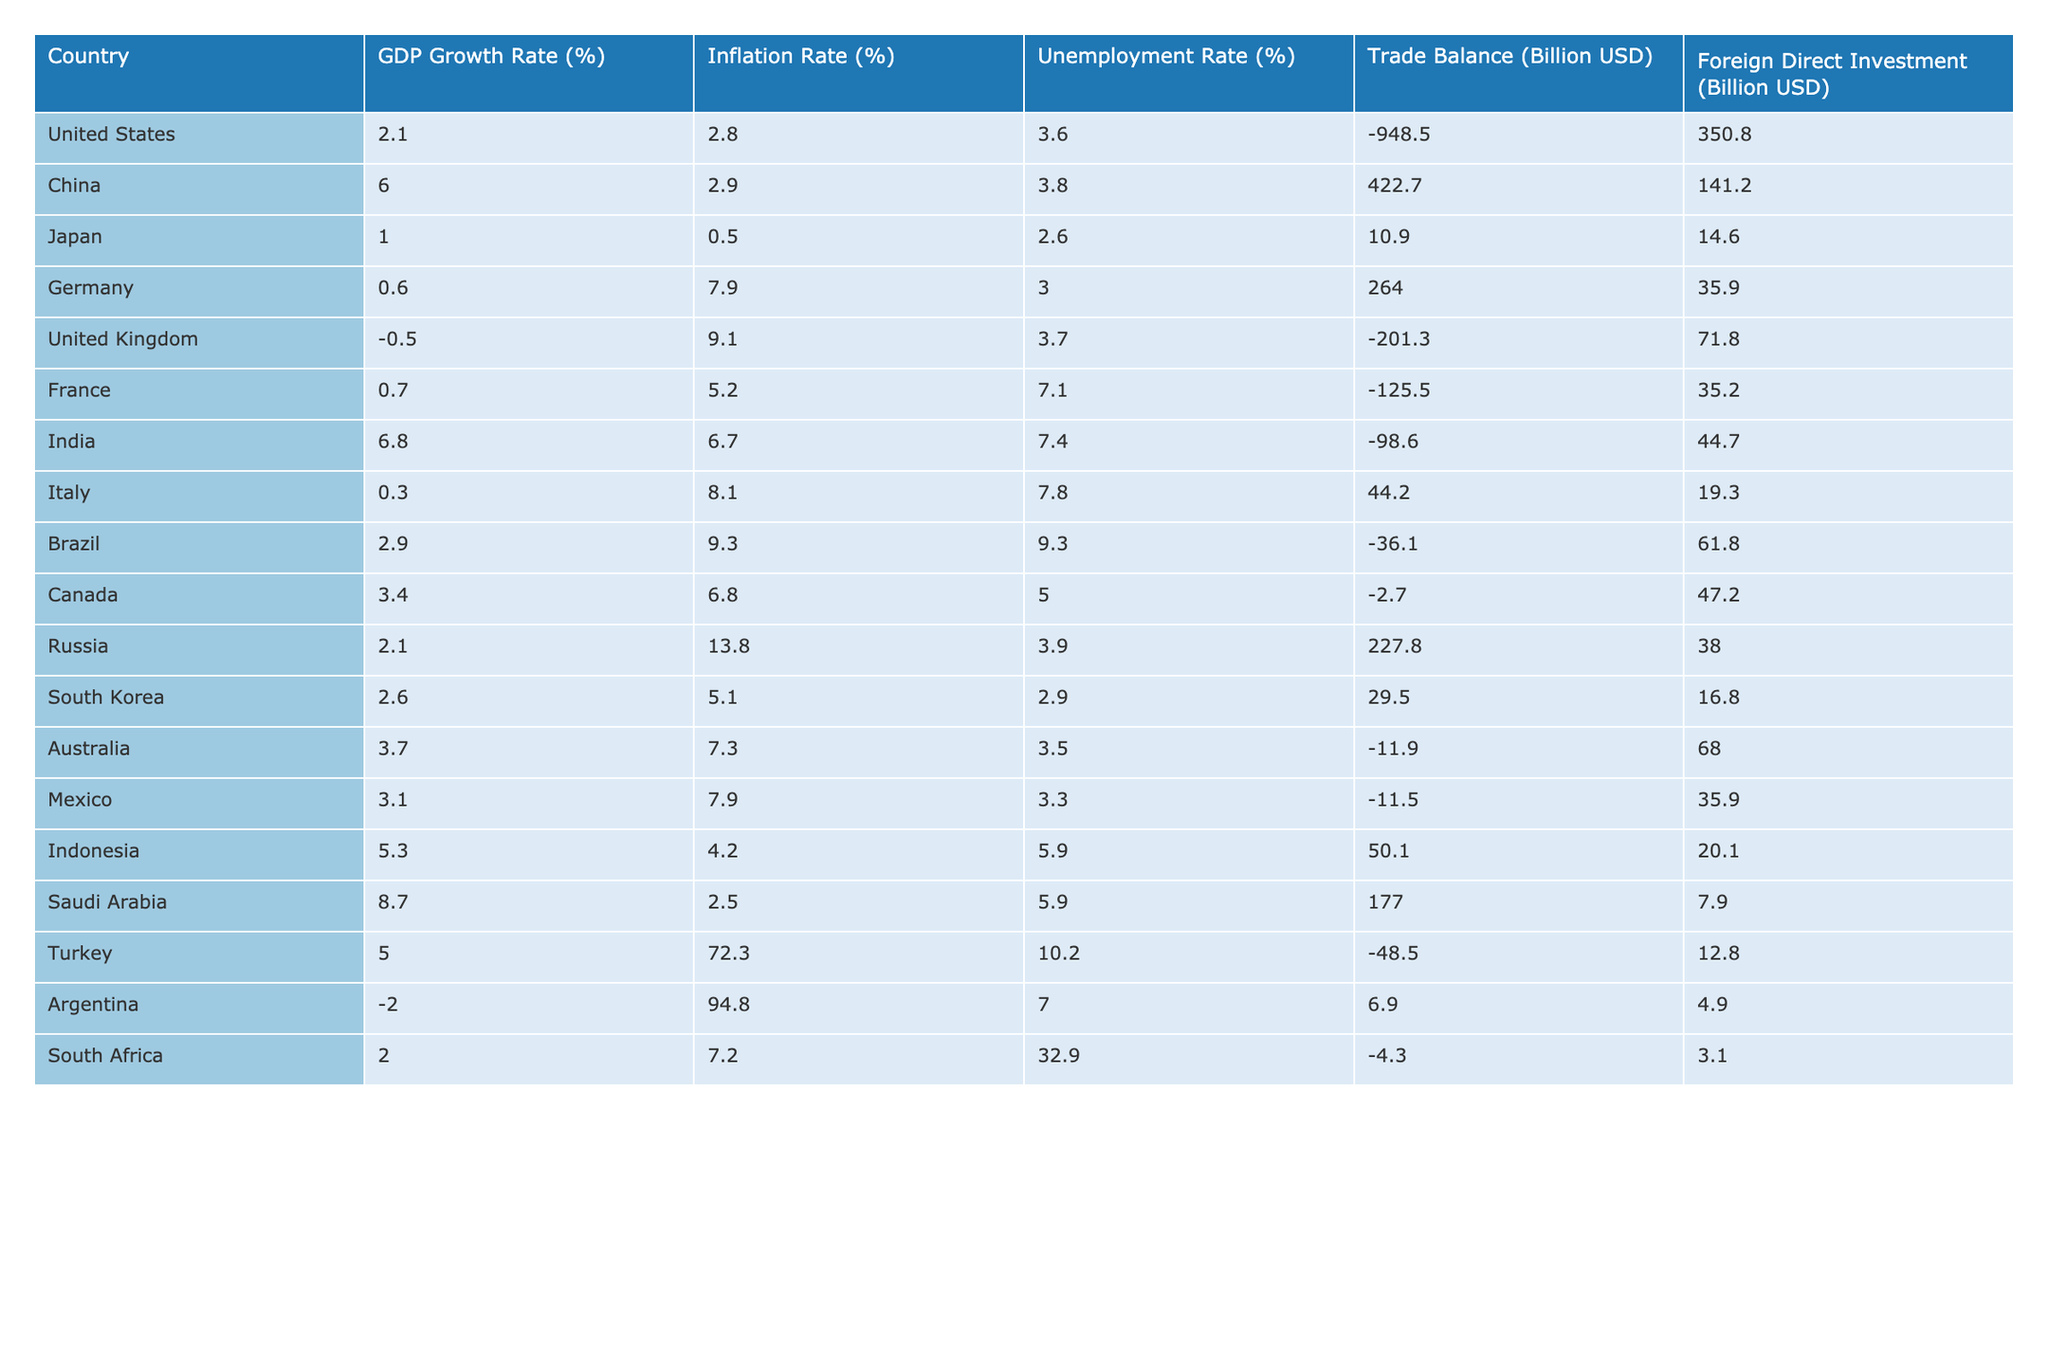What is the GDP growth rate of India? The GDP growth rate for India is directly provided in the table under the "GDP Growth Rate (%)" column. By looking at that specific cell, we find that India's GDP growth rate is 6.8%.
Answer: 6.8% Which country has the highest inflation rate? To find the country with the highest inflation rate, I scan the "Inflation Rate (%)" column to identify the maximum value. The highest inflation rate is 94.8%, which corresponds to Argentina.
Answer: Argentina What is the average unemployment rate of G20 nations? To find the average unemployment rate, I add up all the unemployment rates listed and divide by the number of countries. The total is (3.6 + 3.8 + 2.6 + 3.0 + 3.7 + 7.1 + 7.4 + 7.8 + 9.3 + 5.0 + 3.9 + 2.9 + 3.5 + 3.3 + 5.9 + 10.2 + 7.0 + 32.9) = 90.1 and there are 18 countries, which gives an average of 90.1 / 18 ≈ 5.0%.
Answer: 5.0% Is the trade balance of Japan positive or negative? The trade balance for Japan is shown in the "Trade Balance (Billion USD)" column. Upon checking that entry, we see Japan has a trade balance of 10.9 billion USD, which is positive.
Answer: Yes Which country has the lowest Foreign Direct Investment (FDI)? To determine the country with the lowest FDI, I look through the "Foreign Direct Investment (Billion USD)" column to find the minimum value. The lowest FDI is 3.1 billion USD for South Africa.
Answer: South Africa If we add the GDP growth rates of China and India, what is the result? First, find the GDP growth rates for China (6.0%) and India (6.8%). Adding these two: 6.0 + 6.8 = 12.8%. Thus, the sum of their GDP growth rates is 12.8%.
Answer: 12.8% Is Canada experiencing a higher trade deficit than the United Kingdom? The trade balance of Canada is -2.7 billion USD, while the United Kingdom has a trade balance of -201.3 billion USD. Since -2.7 is less negative than -201.3, Canada’s trade deficit is less than the UK's.
Answer: Yes What is the difference in inflation rates between Turkey and Saudi Arabia? The inflation rate for Turkey is 72.3% and for Saudi Arabia it is 2.5%. To find the difference, subtract the latter from the former: 72.3 - 2.5 = 69.8%. Therefore, the difference in inflation rates is 69.8%.
Answer: 69.8% Which nations have a GDP growth rate below 1%? I inspect the "GDP Growth Rate (%)" column for any values lower than 1%. The only nation with a GDP growth rate below 1% as per the table is Italy with 0.3%.
Answer: Italy 